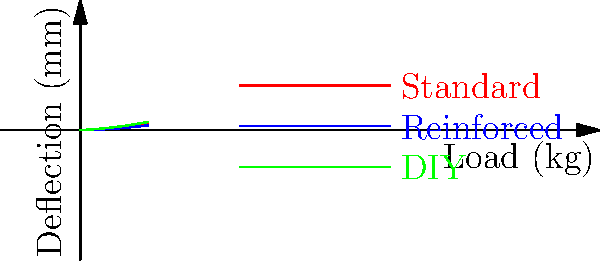As a DIY enthusiast planning a unique shelf installation for your next reality TV show, you've come across three different shelf bracket designs: standard, reinforced, and a custom DIY option. The graph shows the deflection of each bracket type under various loads. If your show requires shelves that can hold up to 40 kg of quirky decor items with minimal visible sagging (less than 3 mm deflection), which bracket design would you recommend to your contestants, and why? To determine the best bracket design for the show, we need to analyze the graph and follow these steps:

1. Identify the load requirement: 40 kg
2. Identify the maximum acceptable deflection: 3 mm
3. Examine each bracket's performance at 40 kg load:

   a. Standard bracket: At 40 kg, deflection ≈ 3.2 mm
   b. Reinforced bracket: At 40 kg, deflection ≈ 2.4 mm
   c. DIY bracket: At 40 kg, deflection ≈ 4.3 mm

4. Compare the deflections to the 3 mm limit:
   - Standard bracket exceeds the limit (3.2 mm > 3 mm)
   - Reinforced bracket is within the limit (2.4 mm < 3 mm)
   - DIY bracket significantly exceeds the limit (4.3 mm > 3 mm)

5. Consider the show's requirements:
   - Need to hold 40 kg of quirky decor
   - Minimal visible sagging (less than 3 mm deflection)
   - Unique DIY aspect for the reality TV show

6. Make a recommendation based on performance and show requirements:
   The reinforced bracket is the only option that meets the load-bearing and deflection requirements. However, to incorporate a DIY element for the show, contestants could be challenged to create a custom reinforcement for the standard bracket, aiming to match or exceed the performance of the reinforced bracket.
Answer: Reinforced bracket, with a DIY challenge to improve the standard bracket's performance. 